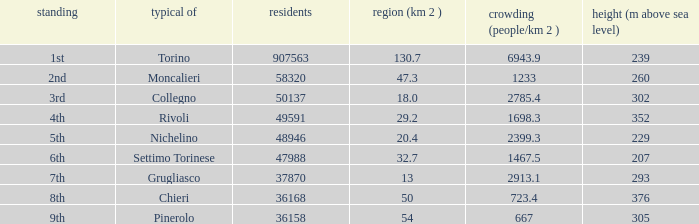Could you parse the entire table as a dict? {'header': ['standing', 'typical of', 'residents', 'region (km 2 )', 'crowding (people/km 2 )', 'height (m above sea level)'], 'rows': [['1st', 'Torino', '907563', '130.7', '6943.9', '239'], ['2nd', 'Moncalieri', '58320', '47.3', '1233', '260'], ['3rd', 'Collegno', '50137', '18.0', '2785.4', '302'], ['4th', 'Rivoli', '49591', '29.2', '1698.3', '352'], ['5th', 'Nichelino', '48946', '20.4', '2399.3', '229'], ['6th', 'Settimo Torinese', '47988', '32.7', '1467.5', '207'], ['7th', 'Grugliasco', '37870', '13', '2913.1', '293'], ['8th', 'Chieri', '36168', '50', '723.4', '376'], ['9th', 'Pinerolo', '36158', '54', '667', '305']]} What common is listed as the 9th in ranking? Pinerolo. 